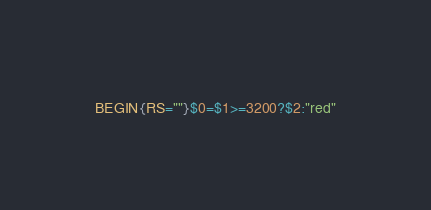Convert code to text. <code><loc_0><loc_0><loc_500><loc_500><_Awk_>BEGIN{RS=""}$0=$1>=3200?$2:"red"</code> 